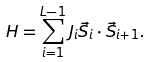<formula> <loc_0><loc_0><loc_500><loc_500>H = \sum _ { i = 1 } ^ { L - 1 } J _ { i } \vec { S } _ { i } \cdot \vec { S } _ { i + 1 } .</formula> 